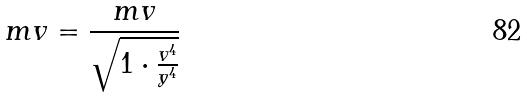<formula> <loc_0><loc_0><loc_500><loc_500>m v = \frac { m v } { \sqrt { 1 \cdot \frac { v ^ { 4 } } { y ^ { 4 } } } }</formula> 